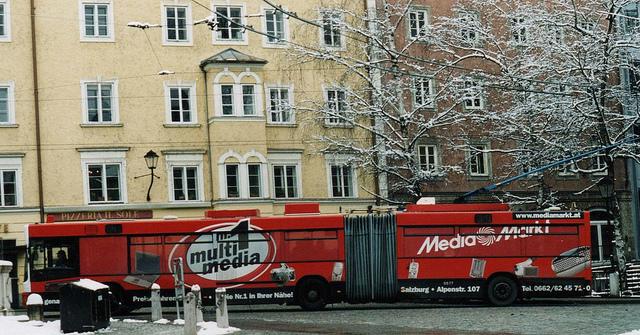What color is the bus?
Answer briefly. Red. Who is advertising on the bus?
Give a very brief answer. Multimedia. Is the bus at a bus stop?
Quick response, please. Yes. 